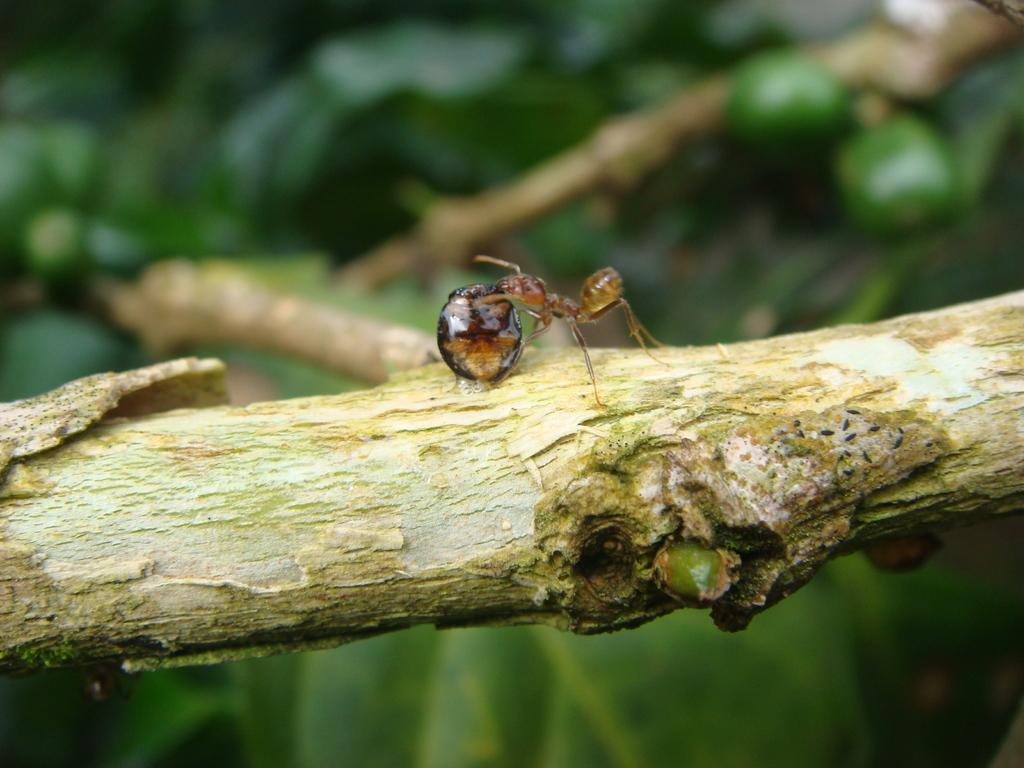What is the main subject of the image? The main subject of the image is an ant. Where is the ant located in the image? The ant is standing on a branch of a tree. What is the father of the ant doing in the image? There is no father of the ant present in the image, as ants do not have individual parents. 